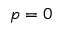Convert formula to latex. <formula><loc_0><loc_0><loc_500><loc_500>p = 0</formula> 